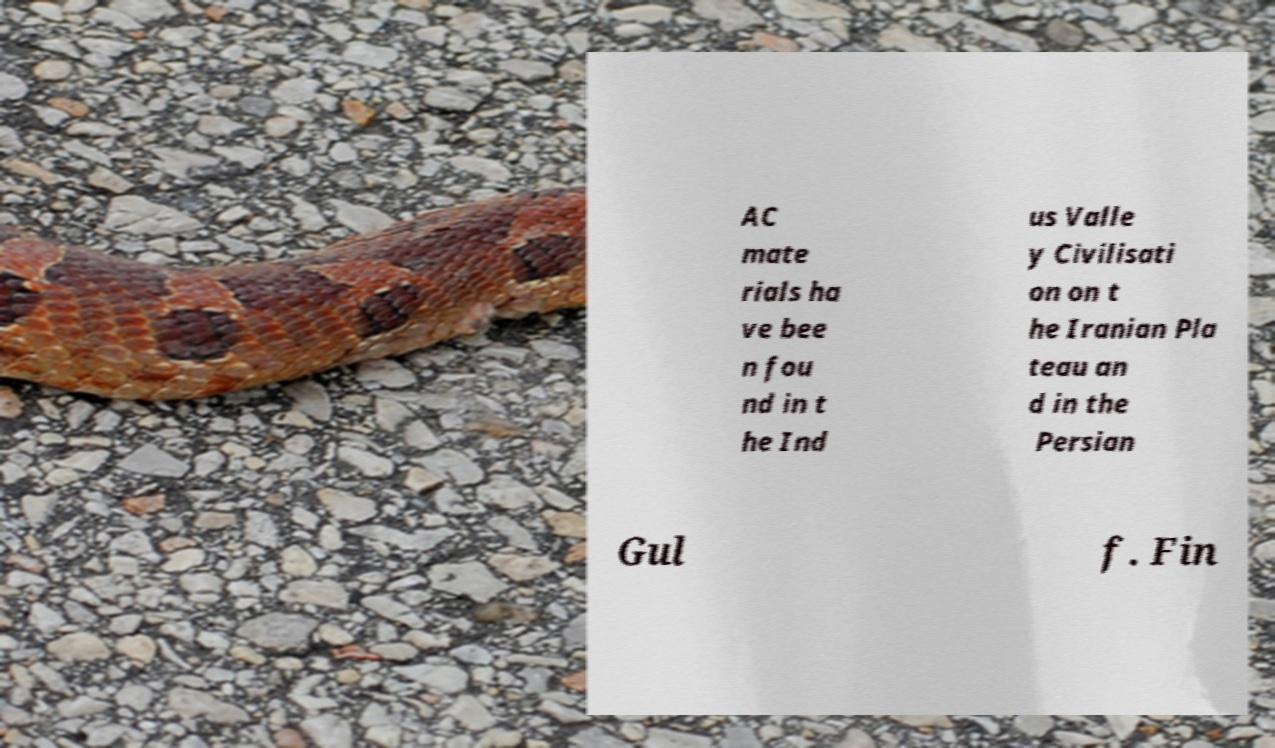Could you extract and type out the text from this image? AC mate rials ha ve bee n fou nd in t he Ind us Valle y Civilisati on on t he Iranian Pla teau an d in the Persian Gul f. Fin 